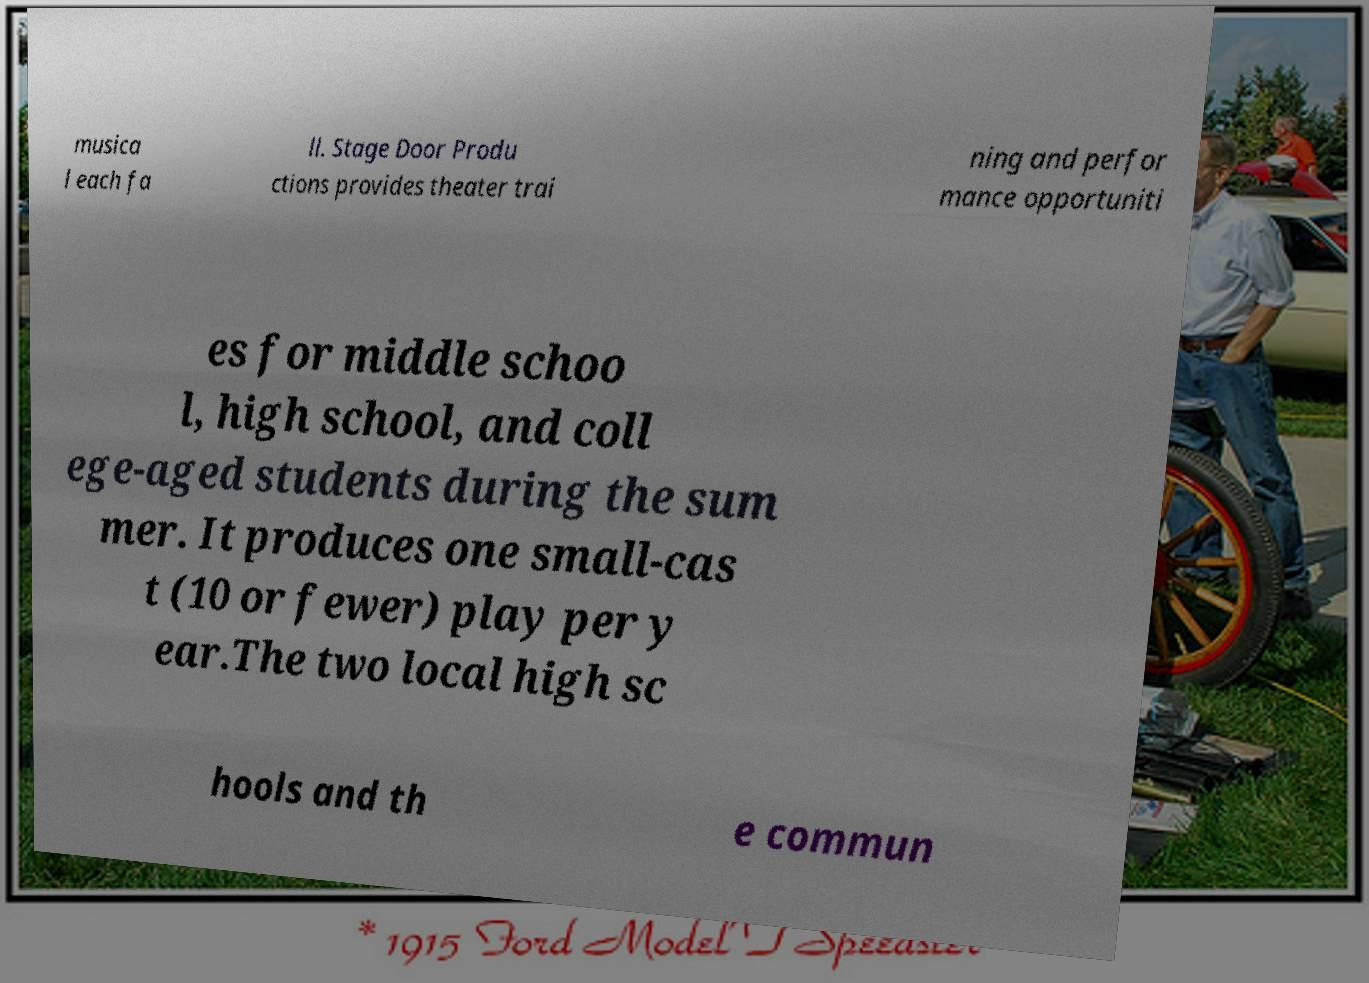There's text embedded in this image that I need extracted. Can you transcribe it verbatim? musica l each fa ll. Stage Door Produ ctions provides theater trai ning and perfor mance opportuniti es for middle schoo l, high school, and coll ege-aged students during the sum mer. It produces one small-cas t (10 or fewer) play per y ear.The two local high sc hools and th e commun 